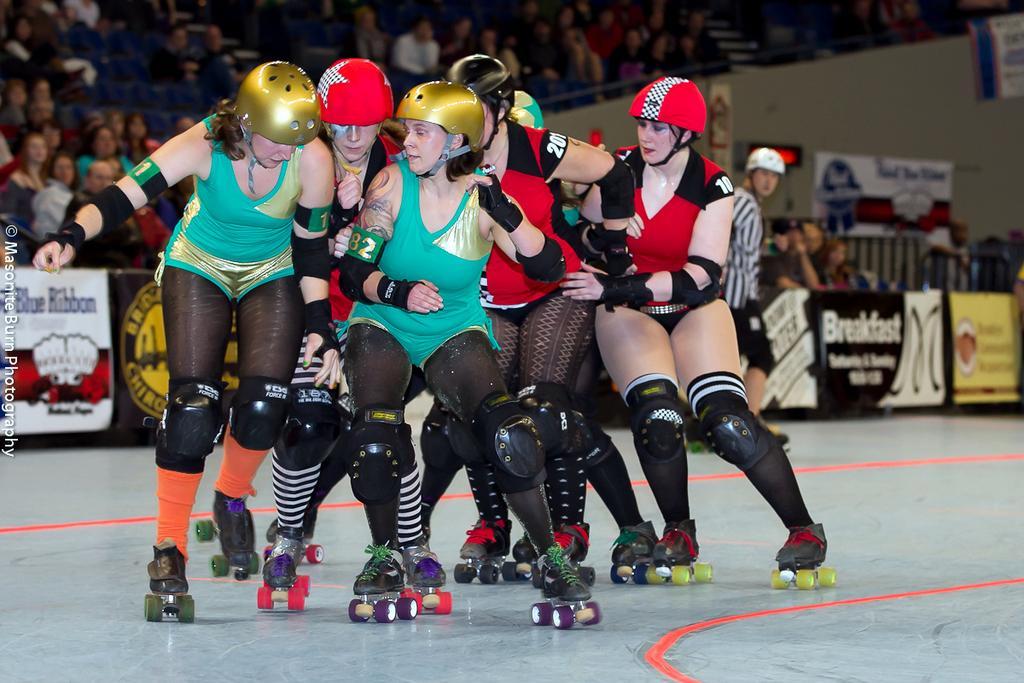In one or two sentences, can you explain what this image depicts? In this image in the center there are a group of people who are skating, and in the background there are some people who are sitting and also there are some boards and wall. At the bottom there is a floor. 